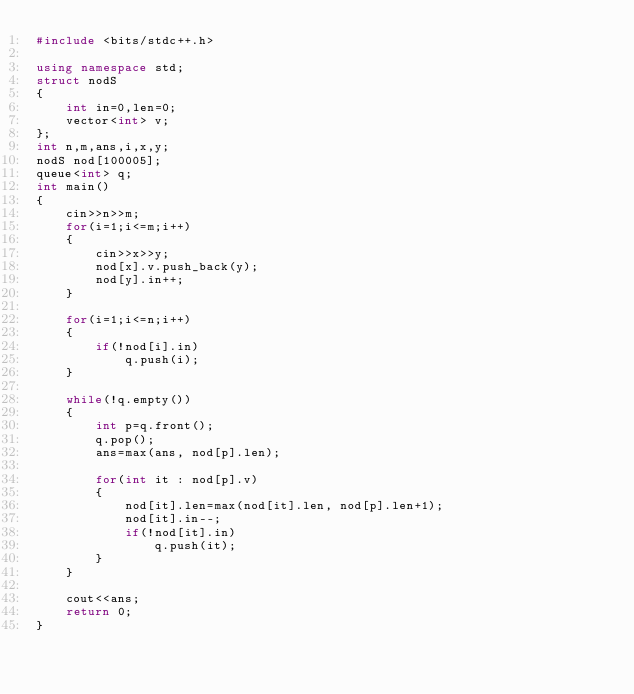Convert code to text. <code><loc_0><loc_0><loc_500><loc_500><_C++_>#include <bits/stdc++.h>

using namespace std;
struct nodS
{
    int in=0,len=0;
    vector<int> v;
};
int n,m,ans,i,x,y;
nodS nod[100005];
queue<int> q;
int main()
{
    cin>>n>>m;
    for(i=1;i<=m;i++)
    {
        cin>>x>>y;
        nod[x].v.push_back(y);
        nod[y].in++;
    }

    for(i=1;i<=n;i++)
    {
        if(!nod[i].in)
            q.push(i);
    }

    while(!q.empty())
    {
        int p=q.front();
        q.pop();
        ans=max(ans, nod[p].len);

        for(int it : nod[p].v)
        {
            nod[it].len=max(nod[it].len, nod[p].len+1);
            nod[it].in--;
            if(!nod[it].in)
                q.push(it);
        }
    }

    cout<<ans;
    return 0;
}
</code> 